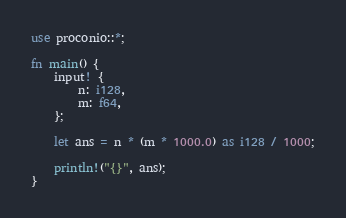<code> <loc_0><loc_0><loc_500><loc_500><_Rust_>use proconio::*;

fn main() {
    input! {
        n: i128,
        m: f64,
    };

    let ans = n * (m * 1000.0) as i128 / 1000;

    println!("{}", ans);
}
</code> 